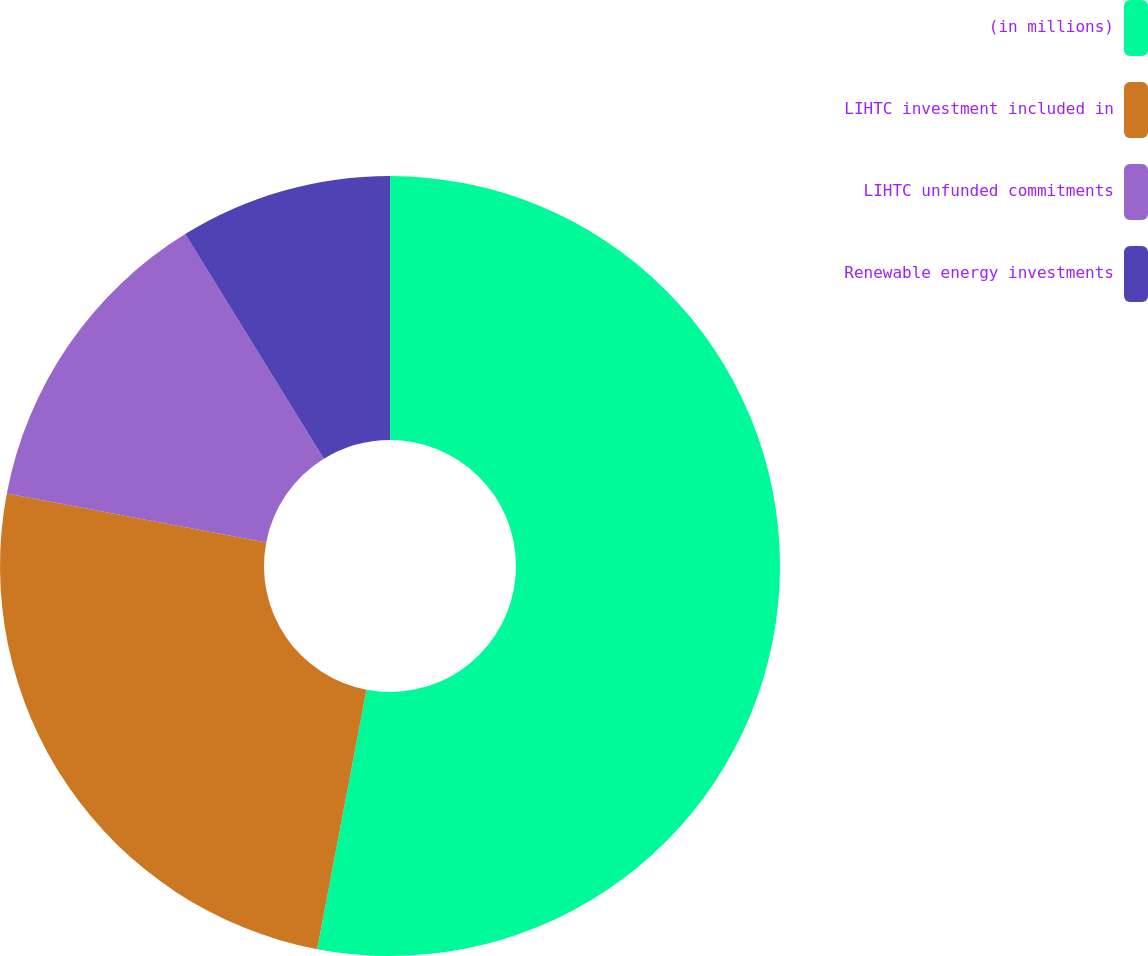Convert chart to OTSL. <chart><loc_0><loc_0><loc_500><loc_500><pie_chart><fcel>(in millions)<fcel>LIHTC investment included in<fcel>LIHTC unfunded commitments<fcel>Renewable energy investments<nl><fcel>52.99%<fcel>24.99%<fcel>13.22%<fcel>8.8%<nl></chart> 